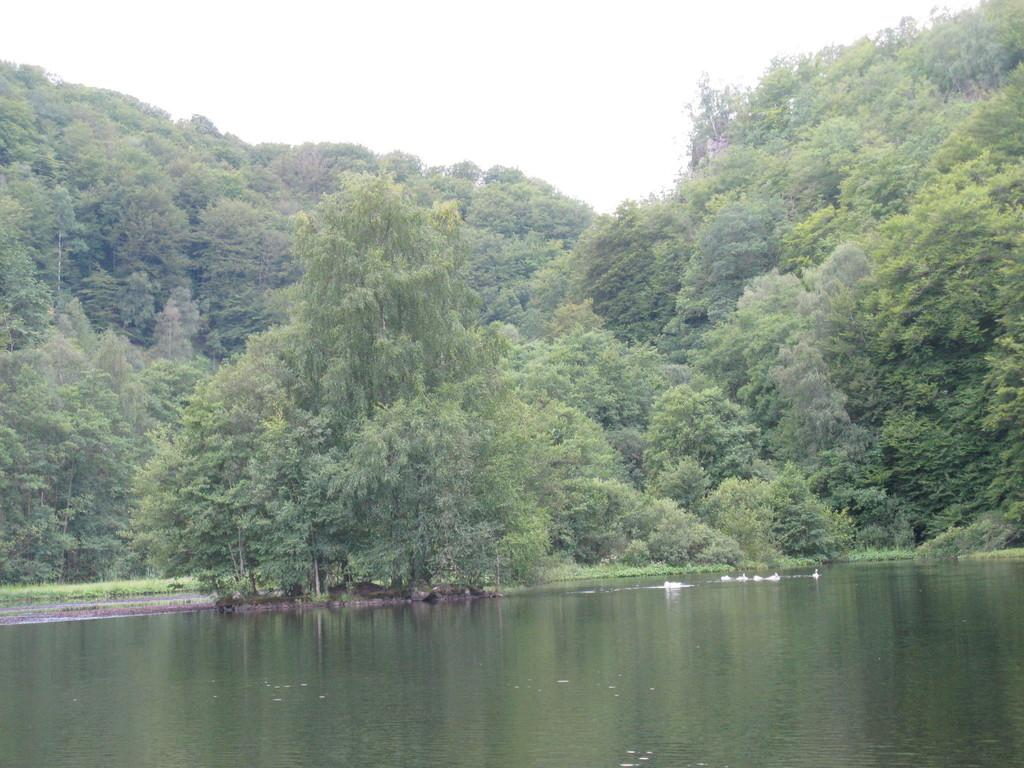What type of vegetation is present in the image? There are green color trees in the image. What natural element can be seen alongside the trees? There is water visible in the image. What is the color of the sky in the image? The sky appears to be white in color. Can you see a tiger working in the image? There is no tiger or any indication of work being done in the image. 